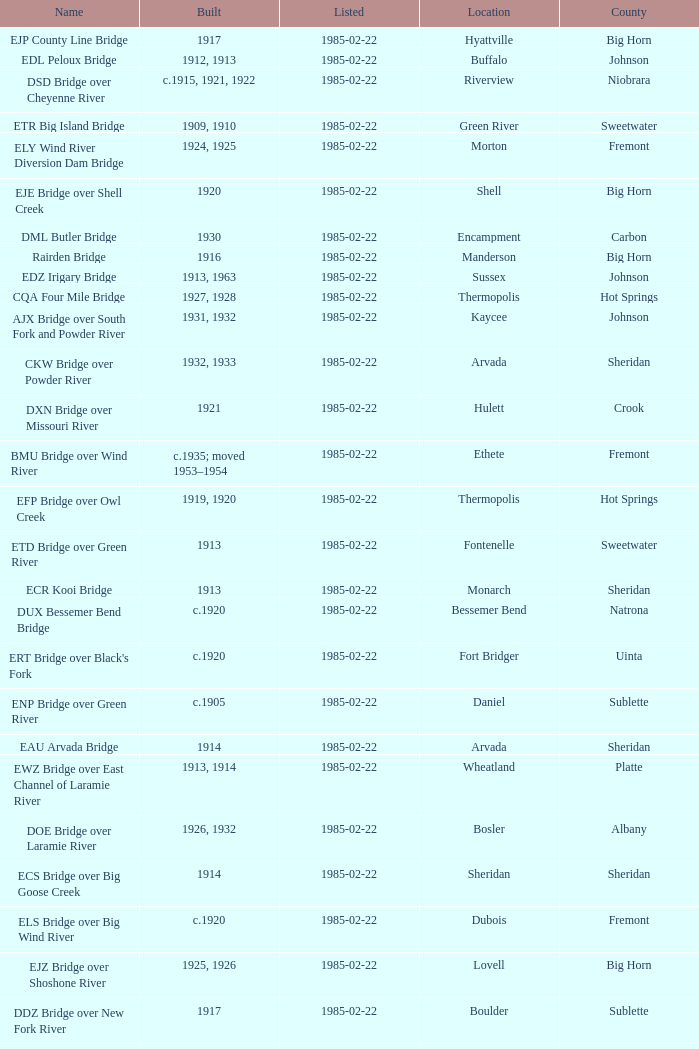What is the listed for the bridge at Daniel in Sublette county? 1985-02-22. 